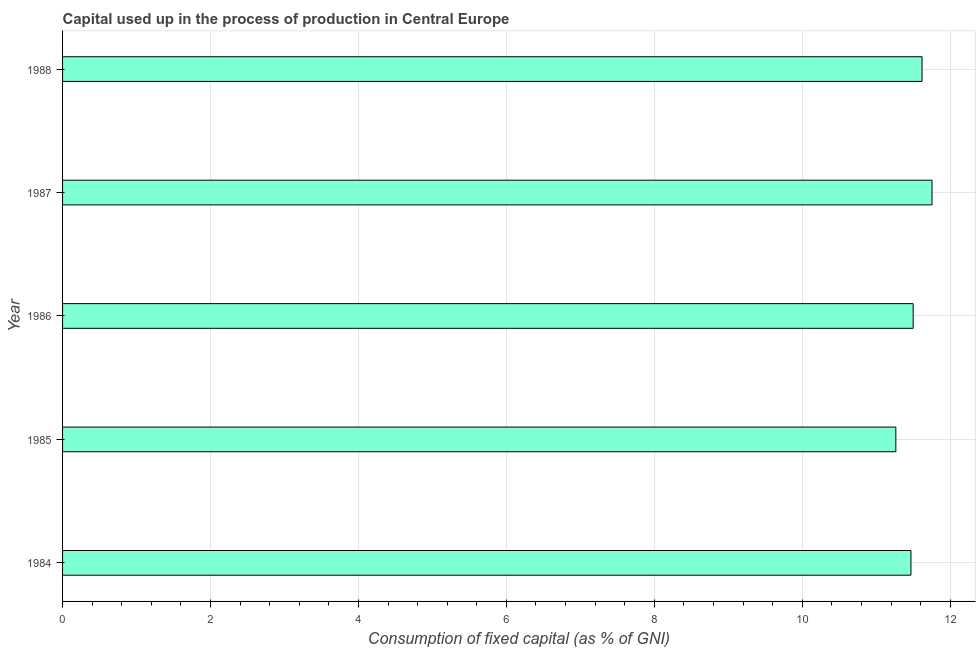Does the graph contain grids?
Provide a short and direct response. Yes. What is the title of the graph?
Offer a terse response. Capital used up in the process of production in Central Europe. What is the label or title of the X-axis?
Ensure brevity in your answer.  Consumption of fixed capital (as % of GNI). What is the label or title of the Y-axis?
Ensure brevity in your answer.  Year. What is the consumption of fixed capital in 1984?
Make the answer very short. 11.47. Across all years, what is the maximum consumption of fixed capital?
Your answer should be very brief. 11.75. Across all years, what is the minimum consumption of fixed capital?
Your answer should be very brief. 11.27. In which year was the consumption of fixed capital maximum?
Your answer should be very brief. 1987. In which year was the consumption of fixed capital minimum?
Your answer should be very brief. 1985. What is the sum of the consumption of fixed capital?
Ensure brevity in your answer.  57.61. What is the difference between the consumption of fixed capital in 1984 and 1987?
Provide a succinct answer. -0.28. What is the average consumption of fixed capital per year?
Offer a terse response. 11.52. What is the median consumption of fixed capital?
Your response must be concise. 11.5. In how many years, is the consumption of fixed capital greater than 4.8 %?
Your answer should be very brief. 5. What is the difference between the highest and the second highest consumption of fixed capital?
Your response must be concise. 0.14. Is the sum of the consumption of fixed capital in 1984 and 1987 greater than the maximum consumption of fixed capital across all years?
Provide a short and direct response. Yes. What is the difference between the highest and the lowest consumption of fixed capital?
Offer a very short reply. 0.49. In how many years, is the consumption of fixed capital greater than the average consumption of fixed capital taken over all years?
Your answer should be compact. 2. Are the values on the major ticks of X-axis written in scientific E-notation?
Ensure brevity in your answer.  No. What is the Consumption of fixed capital (as % of GNI) of 1984?
Ensure brevity in your answer.  11.47. What is the Consumption of fixed capital (as % of GNI) in 1985?
Offer a terse response. 11.27. What is the Consumption of fixed capital (as % of GNI) of 1986?
Offer a terse response. 11.5. What is the Consumption of fixed capital (as % of GNI) in 1987?
Your answer should be very brief. 11.75. What is the Consumption of fixed capital (as % of GNI) of 1988?
Offer a very short reply. 11.62. What is the difference between the Consumption of fixed capital (as % of GNI) in 1984 and 1985?
Make the answer very short. 0.2. What is the difference between the Consumption of fixed capital (as % of GNI) in 1984 and 1986?
Provide a succinct answer. -0.03. What is the difference between the Consumption of fixed capital (as % of GNI) in 1984 and 1987?
Your answer should be very brief. -0.29. What is the difference between the Consumption of fixed capital (as % of GNI) in 1984 and 1988?
Keep it short and to the point. -0.15. What is the difference between the Consumption of fixed capital (as % of GNI) in 1985 and 1986?
Offer a terse response. -0.23. What is the difference between the Consumption of fixed capital (as % of GNI) in 1985 and 1987?
Your answer should be compact. -0.49. What is the difference between the Consumption of fixed capital (as % of GNI) in 1985 and 1988?
Offer a terse response. -0.35. What is the difference between the Consumption of fixed capital (as % of GNI) in 1986 and 1987?
Your answer should be compact. -0.25. What is the difference between the Consumption of fixed capital (as % of GNI) in 1986 and 1988?
Keep it short and to the point. -0.12. What is the difference between the Consumption of fixed capital (as % of GNI) in 1987 and 1988?
Give a very brief answer. 0.13. What is the ratio of the Consumption of fixed capital (as % of GNI) in 1984 to that in 1985?
Make the answer very short. 1.02. What is the ratio of the Consumption of fixed capital (as % of GNI) in 1984 to that in 1986?
Provide a short and direct response. 1. What is the ratio of the Consumption of fixed capital (as % of GNI) in 1985 to that in 1987?
Make the answer very short. 0.96. What is the ratio of the Consumption of fixed capital (as % of GNI) in 1986 to that in 1987?
Ensure brevity in your answer.  0.98. What is the ratio of the Consumption of fixed capital (as % of GNI) in 1987 to that in 1988?
Keep it short and to the point. 1.01. 